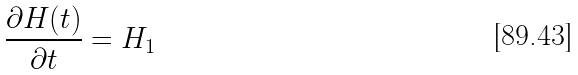Convert formula to latex. <formula><loc_0><loc_0><loc_500><loc_500>\frac { \partial H ( t ) } { \partial t } = H _ { 1 }</formula> 